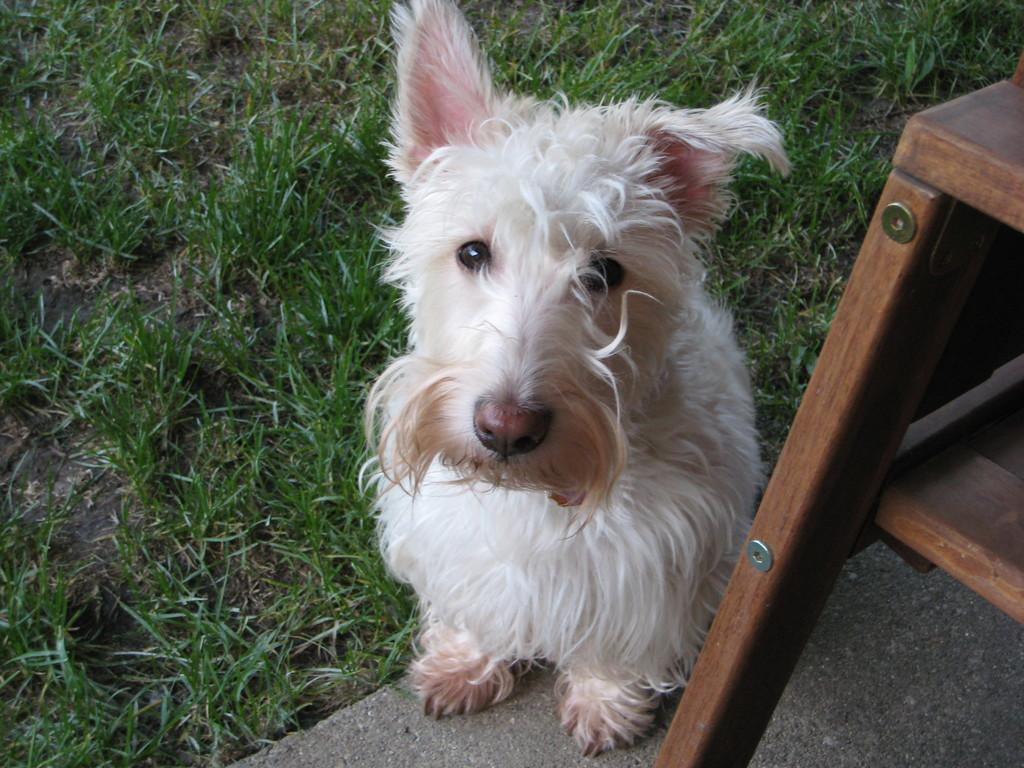What animal is sitting in the image? There is a dog sitting in the image. What object can be seen on the right side of the image? There is a table on the right side of the image. What type of terrain is visible at the bottom of the image? Grass is visible at the bottom of the image. What type of linen is used to cover the table in the image? There is no linen mentioned or visible in the image; only a table is present. 